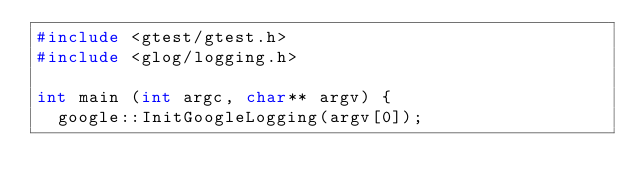Convert code to text. <code><loc_0><loc_0><loc_500><loc_500><_C++_>#include <gtest/gtest.h>
#include <glog/logging.h>

int main (int argc, char** argv) {
  google::InitGoogleLogging(argv[0]);</code> 